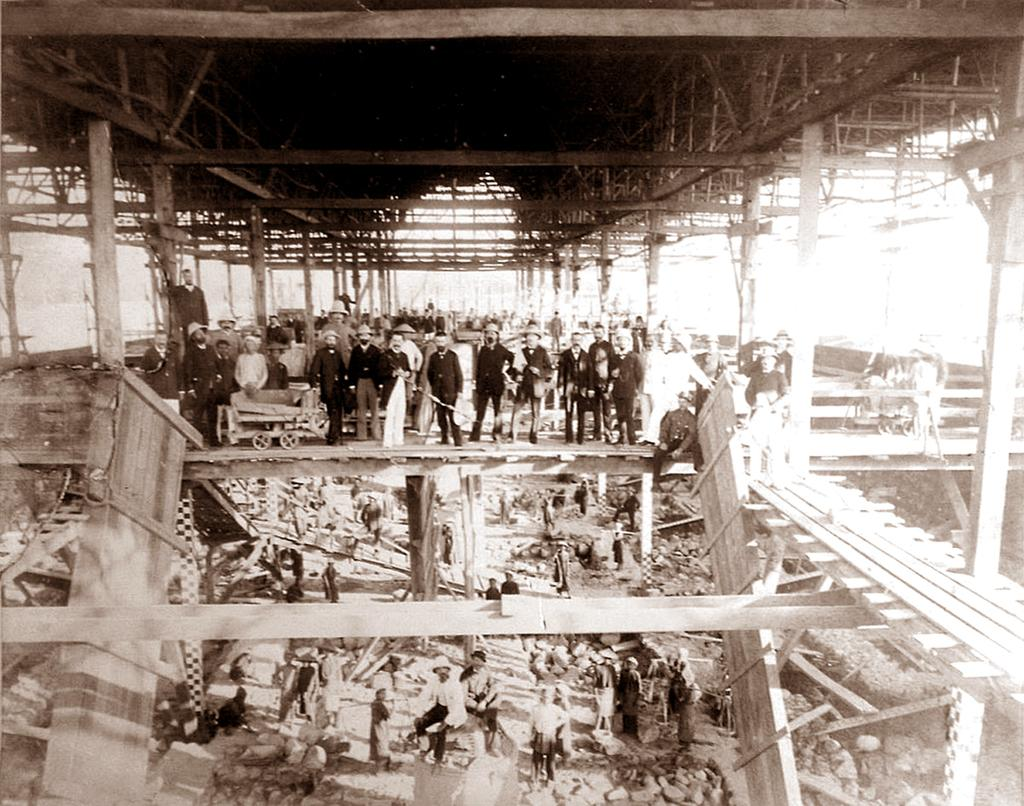How many people are in the group that is visible in the image? The number of people in the group cannot be determined from the provided facts. What is in front of the group of people? There is a trolley in front of the group. What type of objects can be seen in the image? Poles and wooden objects are visible in the image. What type of rhythm can be heard coming from the wooden objects in the image? There is no sound or rhythm present in the image; it is a still image. 